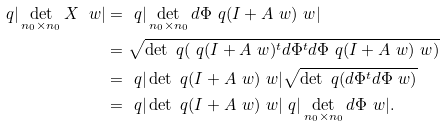<formula> <loc_0><loc_0><loc_500><loc_500>\ q | \det _ { n _ { 0 } \times n _ { 0 } } X \ w | & = \ q | \det _ { n _ { 0 } \times n _ { 0 } } d \Phi \ q ( I + A \ w ) \ w | \\ & = \sqrt { \det \ q ( \ q ( I + A \ w ) ^ { t } d \Phi ^ { t } d \Phi \ q ( I + A \ w ) \ w ) } \\ & = \ q | \det \ q ( I + A \ w ) \ w | \sqrt { \det \ q ( d \Phi ^ { t } d \Phi \ w ) } \\ & = \ q | \det \ q ( I + A \ w ) \ w | \ q | \det _ { n _ { 0 } \times n _ { 0 } } d \Phi \ w | .</formula> 